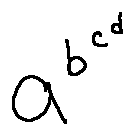<formula> <loc_0><loc_0><loc_500><loc_500>a ^ { b ^ { c ^ { d } } }</formula> 